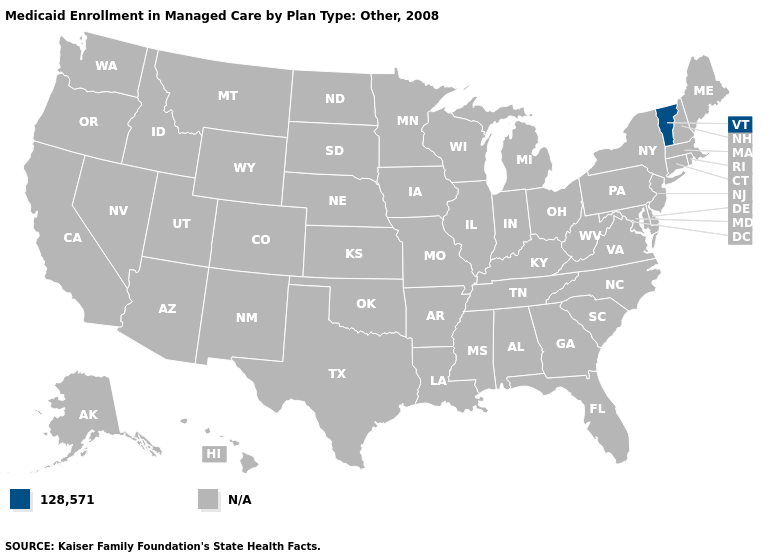What is the value of Connecticut?
Be succinct. N/A. Name the states that have a value in the range N/A?
Quick response, please. Alabama, Alaska, Arizona, Arkansas, California, Colorado, Connecticut, Delaware, Florida, Georgia, Hawaii, Idaho, Illinois, Indiana, Iowa, Kansas, Kentucky, Louisiana, Maine, Maryland, Massachusetts, Michigan, Minnesota, Mississippi, Missouri, Montana, Nebraska, Nevada, New Hampshire, New Jersey, New Mexico, New York, North Carolina, North Dakota, Ohio, Oklahoma, Oregon, Pennsylvania, Rhode Island, South Carolina, South Dakota, Tennessee, Texas, Utah, Virginia, Washington, West Virginia, Wisconsin, Wyoming. Does the first symbol in the legend represent the smallest category?
Write a very short answer. Yes. What is the value of Texas?
Answer briefly. N/A. What is the value of Massachusetts?
Write a very short answer. N/A. What is the value of New Hampshire?
Be succinct. N/A. What is the lowest value in the Northeast?
Answer briefly. 128,571. Name the states that have a value in the range 128,571?
Answer briefly. Vermont. Which states have the highest value in the USA?
Give a very brief answer. Vermont. Name the states that have a value in the range 128,571?
Quick response, please. Vermont. What is the value of Pennsylvania?
Concise answer only. N/A. 